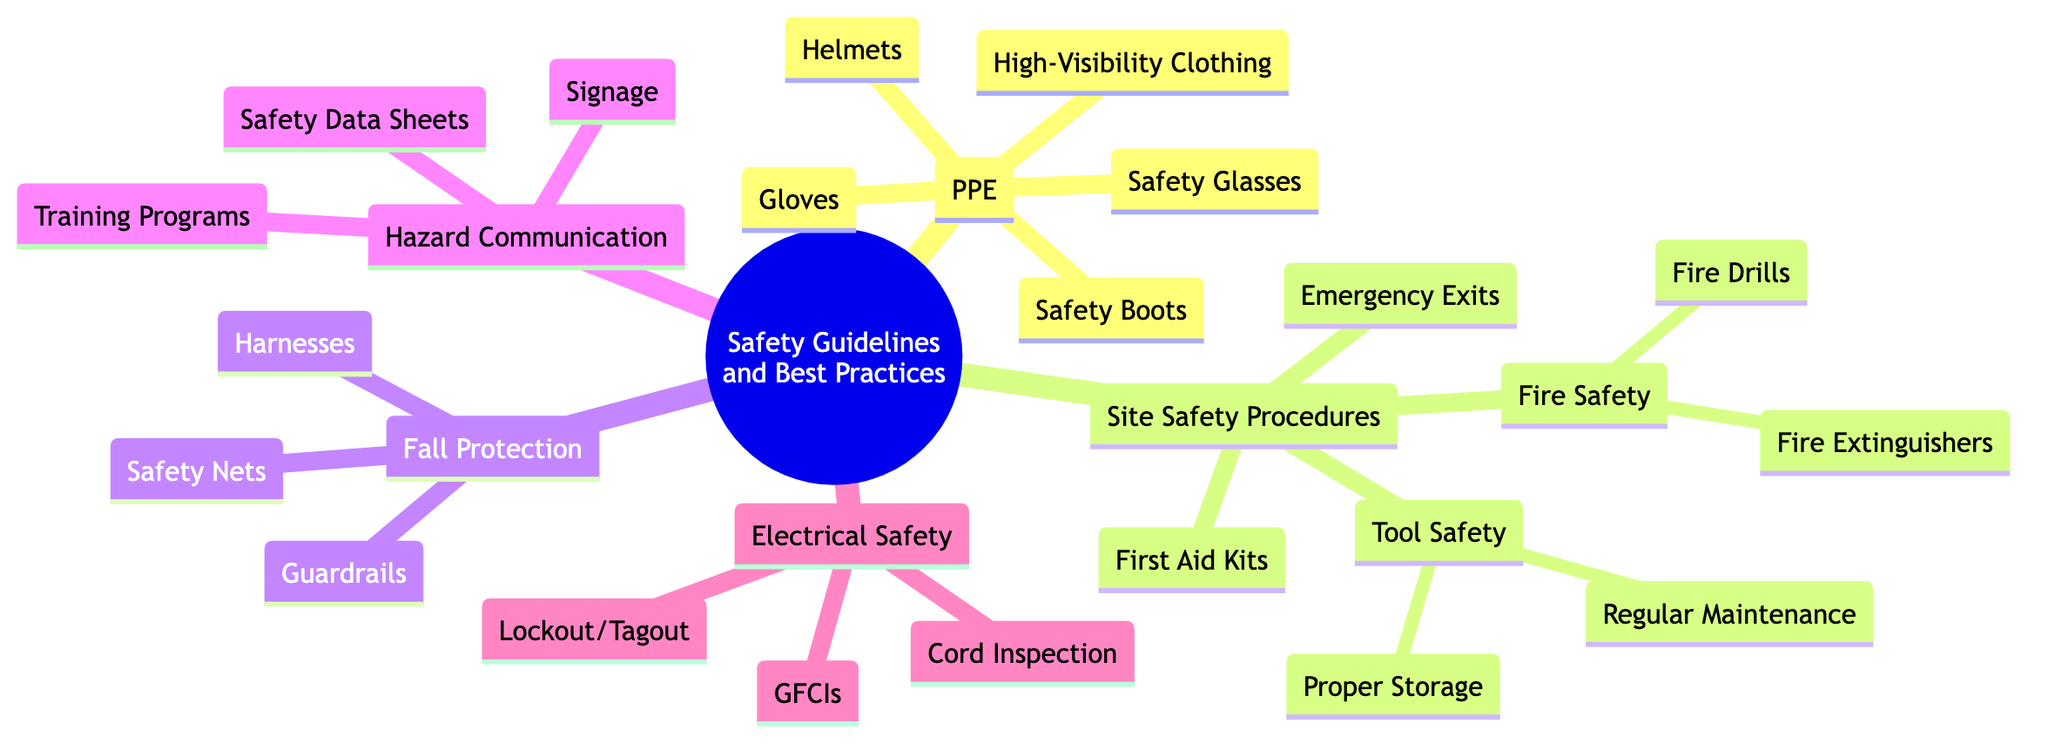What are the main categories under Safety Guidelines and Best Practices? The main categories listed in the diagram include Personal Protective Equipment (PPE), Site Safety Procedures, Fall Protection, Hazard Communication, and Electrical Safety.
Answer: PPE, Site Safety Procedures, Fall Protection, Hazard Communication, Electrical Safety How many types of Personal Protective Equipment are mentioned? The diagram lists five types of Personal Protective Equipment: Helmets, Safety Glasses, Gloves, Safety Boots, and High-Visibility Clothing. Thus, there are a total of five types.
Answer: 5 What safety measure is used when guardrails are not feasible? According to the diagram, Safety Nets are used in situations where guardrails cannot be installed, which serves as an alternative safety measure to prevent falls.
Answer: Safety Nets Which category includes Fire Extinguishers and Fire Drills? Fire Extinguishers and Fire Drills both fall under the category of Fire Safety, which is a subsection of Site Safety Procedures.
Answer: Fire Safety What is the purpose of Lockout/Tagout Procedures? Lockout/Tagout Procedures are intended to ensure that equipment is properly shut off and cannot be restarted during maintenance, as indicated in the Electrical Safety section.
Answer: Ensure equipment is properly shut off Which item is listed as a part of Hazard Communication? The item listed as part of Hazard Communication is Signage, which indicates dangerous areas and required PPE, among other things.
Answer: Signage What type of communication is essential for training on site-specific hazards? Training Programs are essential for educating workers regarding site-specific hazards and safety measures, ensuring they are informed and prepared.
Answer: Training Programs How many items are listed under Fall Protection? The diagram specifies three items under Fall Protection: Guardrails, Safety Nets, and Harnesses, indicating a total of three safety measures in this category.
Answer: 3 What is the main function of First Aid Kits? According to the diagram, the main function of First Aid Kits is to be easily accessible and contain essential medical supplies necessary for treating injuries on site.
Answer: Essential medical supplies 